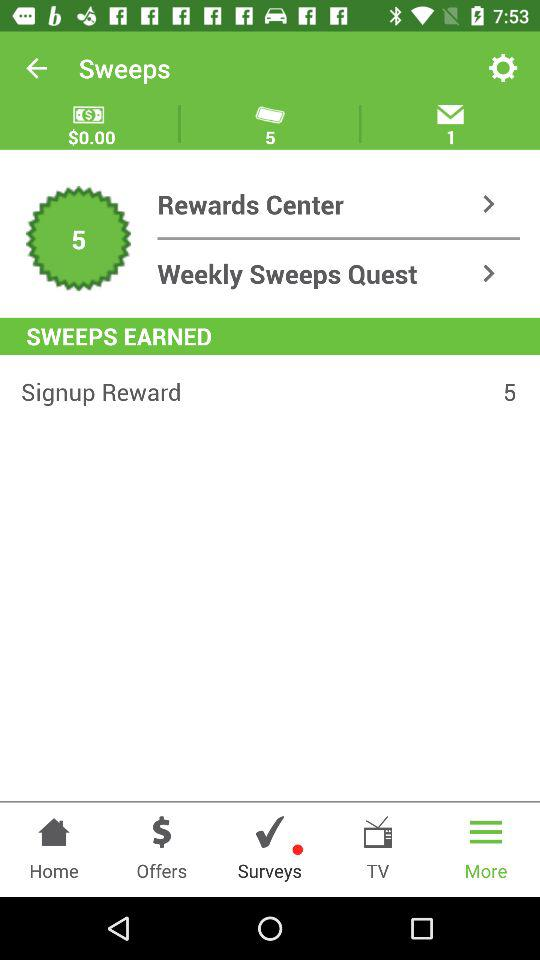How many rewards are there for signing up? There are 5 rewards for signing up. 